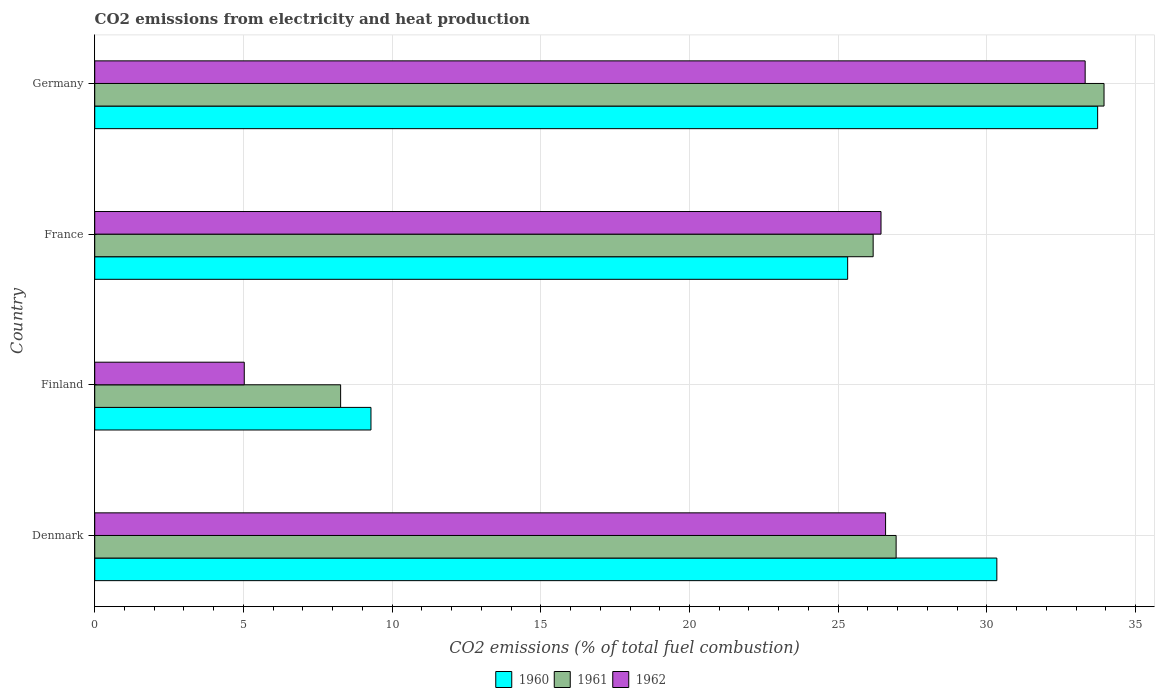How many different coloured bars are there?
Provide a succinct answer. 3. How many groups of bars are there?
Give a very brief answer. 4. Are the number of bars on each tick of the Y-axis equal?
Your response must be concise. Yes. What is the amount of CO2 emitted in 1962 in Denmark?
Provide a short and direct response. 26.59. Across all countries, what is the maximum amount of CO2 emitted in 1962?
Your answer should be compact. 33.31. Across all countries, what is the minimum amount of CO2 emitted in 1960?
Provide a short and direct response. 9.29. In which country was the amount of CO2 emitted in 1960 maximum?
Ensure brevity in your answer.  Germany. What is the total amount of CO2 emitted in 1960 in the graph?
Provide a succinct answer. 98.67. What is the difference between the amount of CO2 emitted in 1960 in Denmark and that in Finland?
Your response must be concise. 21.05. What is the difference between the amount of CO2 emitted in 1962 in Denmark and the amount of CO2 emitted in 1961 in France?
Provide a short and direct response. 0.42. What is the average amount of CO2 emitted in 1962 per country?
Offer a very short reply. 22.84. What is the difference between the amount of CO2 emitted in 1961 and amount of CO2 emitted in 1962 in Germany?
Your answer should be compact. 0.63. In how many countries, is the amount of CO2 emitted in 1960 greater than 16 %?
Offer a very short reply. 3. What is the ratio of the amount of CO2 emitted in 1962 in Denmark to that in Finland?
Your answer should be compact. 5.29. Is the amount of CO2 emitted in 1961 in Denmark less than that in France?
Keep it short and to the point. No. Is the difference between the amount of CO2 emitted in 1961 in France and Germany greater than the difference between the amount of CO2 emitted in 1962 in France and Germany?
Offer a terse response. No. What is the difference between the highest and the second highest amount of CO2 emitted in 1962?
Keep it short and to the point. 6.71. What is the difference between the highest and the lowest amount of CO2 emitted in 1960?
Offer a very short reply. 24.44. What does the 3rd bar from the bottom in Denmark represents?
Offer a very short reply. 1962. Is it the case that in every country, the sum of the amount of CO2 emitted in 1961 and amount of CO2 emitted in 1962 is greater than the amount of CO2 emitted in 1960?
Offer a terse response. Yes. How many bars are there?
Your answer should be very brief. 12. Are all the bars in the graph horizontal?
Offer a terse response. Yes. How many countries are there in the graph?
Ensure brevity in your answer.  4. Does the graph contain any zero values?
Keep it short and to the point. No. Where does the legend appear in the graph?
Offer a very short reply. Bottom center. How are the legend labels stacked?
Your answer should be very brief. Horizontal. What is the title of the graph?
Offer a very short reply. CO2 emissions from electricity and heat production. Does "1984" appear as one of the legend labels in the graph?
Your answer should be very brief. No. What is the label or title of the X-axis?
Offer a very short reply. CO2 emissions (% of total fuel combustion). What is the label or title of the Y-axis?
Make the answer very short. Country. What is the CO2 emissions (% of total fuel combustion) in 1960 in Denmark?
Offer a very short reply. 30.34. What is the CO2 emissions (% of total fuel combustion) in 1961 in Denmark?
Provide a succinct answer. 26.95. What is the CO2 emissions (% of total fuel combustion) of 1962 in Denmark?
Keep it short and to the point. 26.59. What is the CO2 emissions (% of total fuel combustion) of 1960 in Finland?
Your answer should be very brief. 9.29. What is the CO2 emissions (% of total fuel combustion) in 1961 in Finland?
Provide a short and direct response. 8.27. What is the CO2 emissions (% of total fuel combustion) in 1962 in Finland?
Provide a short and direct response. 5.03. What is the CO2 emissions (% of total fuel combustion) in 1960 in France?
Your response must be concise. 25.32. What is the CO2 emissions (% of total fuel combustion) of 1961 in France?
Your answer should be very brief. 26.18. What is the CO2 emissions (% of total fuel combustion) in 1962 in France?
Ensure brevity in your answer.  26.44. What is the CO2 emissions (% of total fuel combustion) in 1960 in Germany?
Your answer should be very brief. 33.72. What is the CO2 emissions (% of total fuel combustion) in 1961 in Germany?
Provide a short and direct response. 33.94. What is the CO2 emissions (% of total fuel combustion) of 1962 in Germany?
Give a very brief answer. 33.31. Across all countries, what is the maximum CO2 emissions (% of total fuel combustion) in 1960?
Give a very brief answer. 33.72. Across all countries, what is the maximum CO2 emissions (% of total fuel combustion) of 1961?
Ensure brevity in your answer.  33.94. Across all countries, what is the maximum CO2 emissions (% of total fuel combustion) in 1962?
Make the answer very short. 33.31. Across all countries, what is the minimum CO2 emissions (% of total fuel combustion) in 1960?
Give a very brief answer. 9.29. Across all countries, what is the minimum CO2 emissions (% of total fuel combustion) in 1961?
Provide a short and direct response. 8.27. Across all countries, what is the minimum CO2 emissions (% of total fuel combustion) of 1962?
Offer a terse response. 5.03. What is the total CO2 emissions (% of total fuel combustion) in 1960 in the graph?
Offer a terse response. 98.67. What is the total CO2 emissions (% of total fuel combustion) in 1961 in the graph?
Provide a succinct answer. 95.33. What is the total CO2 emissions (% of total fuel combustion) of 1962 in the graph?
Make the answer very short. 91.37. What is the difference between the CO2 emissions (% of total fuel combustion) in 1960 in Denmark and that in Finland?
Your answer should be compact. 21.05. What is the difference between the CO2 emissions (% of total fuel combustion) of 1961 in Denmark and that in Finland?
Make the answer very short. 18.68. What is the difference between the CO2 emissions (% of total fuel combustion) of 1962 in Denmark and that in Finland?
Your response must be concise. 21.57. What is the difference between the CO2 emissions (% of total fuel combustion) in 1960 in Denmark and that in France?
Ensure brevity in your answer.  5.02. What is the difference between the CO2 emissions (% of total fuel combustion) in 1961 in Denmark and that in France?
Offer a very short reply. 0.77. What is the difference between the CO2 emissions (% of total fuel combustion) of 1962 in Denmark and that in France?
Provide a succinct answer. 0.15. What is the difference between the CO2 emissions (% of total fuel combustion) of 1960 in Denmark and that in Germany?
Your response must be concise. -3.39. What is the difference between the CO2 emissions (% of total fuel combustion) in 1961 in Denmark and that in Germany?
Make the answer very short. -6.99. What is the difference between the CO2 emissions (% of total fuel combustion) in 1962 in Denmark and that in Germany?
Give a very brief answer. -6.71. What is the difference between the CO2 emissions (% of total fuel combustion) of 1960 in Finland and that in France?
Your answer should be compact. -16.03. What is the difference between the CO2 emissions (% of total fuel combustion) of 1961 in Finland and that in France?
Give a very brief answer. -17.91. What is the difference between the CO2 emissions (% of total fuel combustion) in 1962 in Finland and that in France?
Give a very brief answer. -21.41. What is the difference between the CO2 emissions (% of total fuel combustion) in 1960 in Finland and that in Germany?
Offer a terse response. -24.44. What is the difference between the CO2 emissions (% of total fuel combustion) of 1961 in Finland and that in Germany?
Your answer should be compact. -25.67. What is the difference between the CO2 emissions (% of total fuel combustion) in 1962 in Finland and that in Germany?
Your answer should be compact. -28.28. What is the difference between the CO2 emissions (% of total fuel combustion) in 1960 in France and that in Germany?
Your answer should be very brief. -8.41. What is the difference between the CO2 emissions (% of total fuel combustion) in 1961 in France and that in Germany?
Make the answer very short. -7.76. What is the difference between the CO2 emissions (% of total fuel combustion) of 1962 in France and that in Germany?
Your answer should be compact. -6.87. What is the difference between the CO2 emissions (% of total fuel combustion) of 1960 in Denmark and the CO2 emissions (% of total fuel combustion) of 1961 in Finland?
Ensure brevity in your answer.  22.07. What is the difference between the CO2 emissions (% of total fuel combustion) of 1960 in Denmark and the CO2 emissions (% of total fuel combustion) of 1962 in Finland?
Give a very brief answer. 25.31. What is the difference between the CO2 emissions (% of total fuel combustion) in 1961 in Denmark and the CO2 emissions (% of total fuel combustion) in 1962 in Finland?
Offer a terse response. 21.92. What is the difference between the CO2 emissions (% of total fuel combustion) of 1960 in Denmark and the CO2 emissions (% of total fuel combustion) of 1961 in France?
Ensure brevity in your answer.  4.16. What is the difference between the CO2 emissions (% of total fuel combustion) in 1960 in Denmark and the CO2 emissions (% of total fuel combustion) in 1962 in France?
Your answer should be very brief. 3.9. What is the difference between the CO2 emissions (% of total fuel combustion) of 1961 in Denmark and the CO2 emissions (% of total fuel combustion) of 1962 in France?
Your response must be concise. 0.51. What is the difference between the CO2 emissions (% of total fuel combustion) in 1960 in Denmark and the CO2 emissions (% of total fuel combustion) in 1961 in Germany?
Offer a very short reply. -3.6. What is the difference between the CO2 emissions (% of total fuel combustion) of 1960 in Denmark and the CO2 emissions (% of total fuel combustion) of 1962 in Germany?
Keep it short and to the point. -2.97. What is the difference between the CO2 emissions (% of total fuel combustion) of 1961 in Denmark and the CO2 emissions (% of total fuel combustion) of 1962 in Germany?
Offer a terse response. -6.36. What is the difference between the CO2 emissions (% of total fuel combustion) of 1960 in Finland and the CO2 emissions (% of total fuel combustion) of 1961 in France?
Your response must be concise. -16.89. What is the difference between the CO2 emissions (% of total fuel combustion) of 1960 in Finland and the CO2 emissions (% of total fuel combustion) of 1962 in France?
Your answer should be very brief. -17.15. What is the difference between the CO2 emissions (% of total fuel combustion) in 1961 in Finland and the CO2 emissions (% of total fuel combustion) in 1962 in France?
Give a very brief answer. -18.17. What is the difference between the CO2 emissions (% of total fuel combustion) in 1960 in Finland and the CO2 emissions (% of total fuel combustion) in 1961 in Germany?
Offer a terse response. -24.65. What is the difference between the CO2 emissions (% of total fuel combustion) of 1960 in Finland and the CO2 emissions (% of total fuel combustion) of 1962 in Germany?
Offer a terse response. -24.02. What is the difference between the CO2 emissions (% of total fuel combustion) of 1961 in Finland and the CO2 emissions (% of total fuel combustion) of 1962 in Germany?
Provide a succinct answer. -25.04. What is the difference between the CO2 emissions (% of total fuel combustion) in 1960 in France and the CO2 emissions (% of total fuel combustion) in 1961 in Germany?
Provide a short and direct response. -8.62. What is the difference between the CO2 emissions (% of total fuel combustion) in 1960 in France and the CO2 emissions (% of total fuel combustion) in 1962 in Germany?
Offer a terse response. -7.99. What is the difference between the CO2 emissions (% of total fuel combustion) in 1961 in France and the CO2 emissions (% of total fuel combustion) in 1962 in Germany?
Your answer should be compact. -7.13. What is the average CO2 emissions (% of total fuel combustion) of 1960 per country?
Keep it short and to the point. 24.67. What is the average CO2 emissions (% of total fuel combustion) of 1961 per country?
Your answer should be compact. 23.83. What is the average CO2 emissions (% of total fuel combustion) in 1962 per country?
Give a very brief answer. 22.84. What is the difference between the CO2 emissions (% of total fuel combustion) of 1960 and CO2 emissions (% of total fuel combustion) of 1961 in Denmark?
Keep it short and to the point. 3.39. What is the difference between the CO2 emissions (% of total fuel combustion) of 1960 and CO2 emissions (% of total fuel combustion) of 1962 in Denmark?
Ensure brevity in your answer.  3.74. What is the difference between the CO2 emissions (% of total fuel combustion) in 1961 and CO2 emissions (% of total fuel combustion) in 1962 in Denmark?
Ensure brevity in your answer.  0.35. What is the difference between the CO2 emissions (% of total fuel combustion) of 1960 and CO2 emissions (% of total fuel combustion) of 1961 in Finland?
Offer a terse response. 1.02. What is the difference between the CO2 emissions (% of total fuel combustion) of 1960 and CO2 emissions (% of total fuel combustion) of 1962 in Finland?
Your response must be concise. 4.26. What is the difference between the CO2 emissions (% of total fuel combustion) in 1961 and CO2 emissions (% of total fuel combustion) in 1962 in Finland?
Offer a very short reply. 3.24. What is the difference between the CO2 emissions (% of total fuel combustion) in 1960 and CO2 emissions (% of total fuel combustion) in 1961 in France?
Your answer should be very brief. -0.86. What is the difference between the CO2 emissions (% of total fuel combustion) in 1960 and CO2 emissions (% of total fuel combustion) in 1962 in France?
Offer a very short reply. -1.12. What is the difference between the CO2 emissions (% of total fuel combustion) in 1961 and CO2 emissions (% of total fuel combustion) in 1962 in France?
Your answer should be compact. -0.26. What is the difference between the CO2 emissions (% of total fuel combustion) of 1960 and CO2 emissions (% of total fuel combustion) of 1961 in Germany?
Your answer should be very brief. -0.21. What is the difference between the CO2 emissions (% of total fuel combustion) of 1960 and CO2 emissions (% of total fuel combustion) of 1962 in Germany?
Provide a succinct answer. 0.42. What is the difference between the CO2 emissions (% of total fuel combustion) of 1961 and CO2 emissions (% of total fuel combustion) of 1962 in Germany?
Provide a succinct answer. 0.63. What is the ratio of the CO2 emissions (% of total fuel combustion) of 1960 in Denmark to that in Finland?
Make the answer very short. 3.27. What is the ratio of the CO2 emissions (% of total fuel combustion) in 1961 in Denmark to that in Finland?
Your answer should be compact. 3.26. What is the ratio of the CO2 emissions (% of total fuel combustion) in 1962 in Denmark to that in Finland?
Keep it short and to the point. 5.29. What is the ratio of the CO2 emissions (% of total fuel combustion) in 1960 in Denmark to that in France?
Ensure brevity in your answer.  1.2. What is the ratio of the CO2 emissions (% of total fuel combustion) of 1961 in Denmark to that in France?
Provide a short and direct response. 1.03. What is the ratio of the CO2 emissions (% of total fuel combustion) in 1960 in Denmark to that in Germany?
Your answer should be compact. 0.9. What is the ratio of the CO2 emissions (% of total fuel combustion) of 1961 in Denmark to that in Germany?
Provide a short and direct response. 0.79. What is the ratio of the CO2 emissions (% of total fuel combustion) in 1962 in Denmark to that in Germany?
Keep it short and to the point. 0.8. What is the ratio of the CO2 emissions (% of total fuel combustion) of 1960 in Finland to that in France?
Your answer should be compact. 0.37. What is the ratio of the CO2 emissions (% of total fuel combustion) of 1961 in Finland to that in France?
Make the answer very short. 0.32. What is the ratio of the CO2 emissions (% of total fuel combustion) of 1962 in Finland to that in France?
Your response must be concise. 0.19. What is the ratio of the CO2 emissions (% of total fuel combustion) of 1960 in Finland to that in Germany?
Your answer should be very brief. 0.28. What is the ratio of the CO2 emissions (% of total fuel combustion) in 1961 in Finland to that in Germany?
Make the answer very short. 0.24. What is the ratio of the CO2 emissions (% of total fuel combustion) of 1962 in Finland to that in Germany?
Keep it short and to the point. 0.15. What is the ratio of the CO2 emissions (% of total fuel combustion) of 1960 in France to that in Germany?
Provide a succinct answer. 0.75. What is the ratio of the CO2 emissions (% of total fuel combustion) of 1961 in France to that in Germany?
Your answer should be very brief. 0.77. What is the ratio of the CO2 emissions (% of total fuel combustion) of 1962 in France to that in Germany?
Offer a terse response. 0.79. What is the difference between the highest and the second highest CO2 emissions (% of total fuel combustion) of 1960?
Provide a short and direct response. 3.39. What is the difference between the highest and the second highest CO2 emissions (% of total fuel combustion) of 1961?
Keep it short and to the point. 6.99. What is the difference between the highest and the second highest CO2 emissions (% of total fuel combustion) of 1962?
Your response must be concise. 6.71. What is the difference between the highest and the lowest CO2 emissions (% of total fuel combustion) of 1960?
Make the answer very short. 24.44. What is the difference between the highest and the lowest CO2 emissions (% of total fuel combustion) of 1961?
Provide a short and direct response. 25.67. What is the difference between the highest and the lowest CO2 emissions (% of total fuel combustion) in 1962?
Provide a short and direct response. 28.28. 